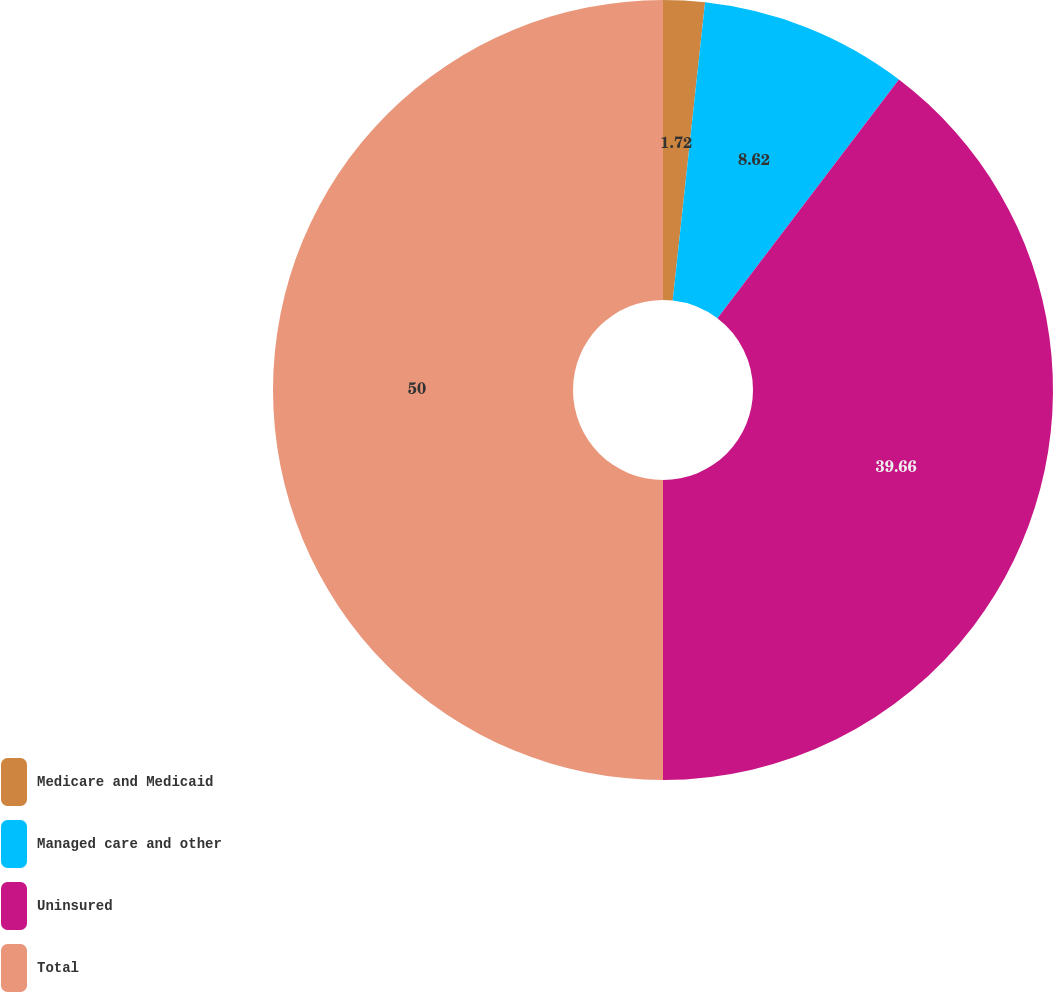<chart> <loc_0><loc_0><loc_500><loc_500><pie_chart><fcel>Medicare and Medicaid<fcel>Managed care and other<fcel>Uninsured<fcel>Total<nl><fcel>1.72%<fcel>8.62%<fcel>39.66%<fcel>50.0%<nl></chart> 